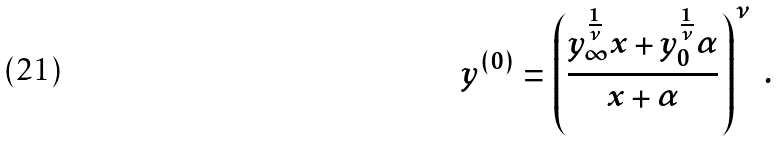<formula> <loc_0><loc_0><loc_500><loc_500>y ^ { ( 0 ) } = \left ( \frac { y _ { \infty } ^ { \frac { 1 } { \nu } } x + y _ { 0 } ^ { \frac { 1 } { \nu } } \alpha } { x + \alpha } \right ) ^ { \nu } \ .</formula> 